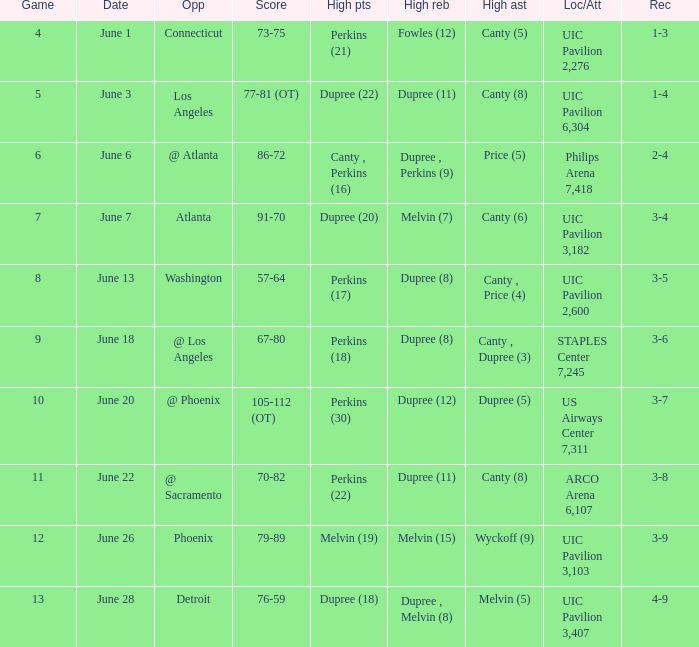Who had the most assists in the game that led to a 3-7 record? Dupree (5). 